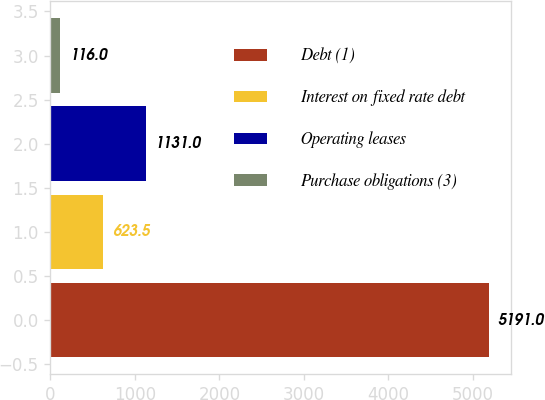Convert chart. <chart><loc_0><loc_0><loc_500><loc_500><bar_chart><fcel>Debt (1)<fcel>Interest on fixed rate debt<fcel>Operating leases<fcel>Purchase obligations (3)<nl><fcel>5191<fcel>623.5<fcel>1131<fcel>116<nl></chart> 